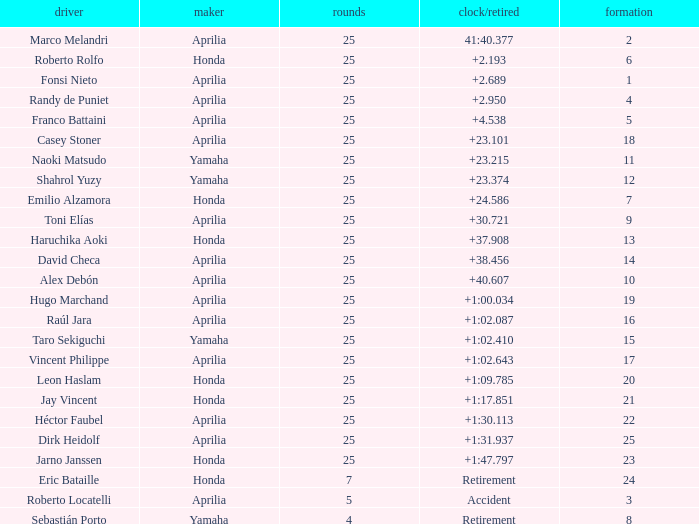Which Manufacturer has a Time/Retired of accident? Aprilia. 